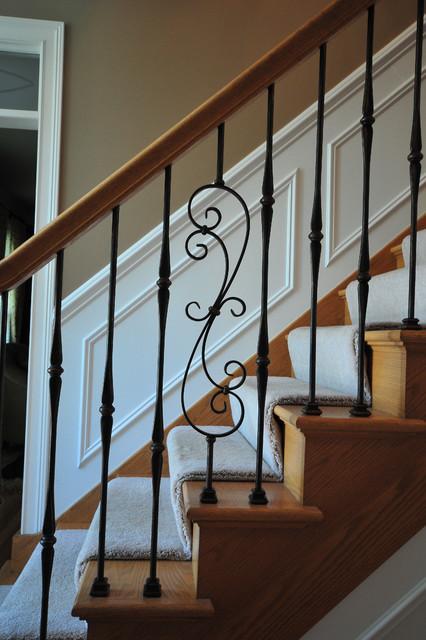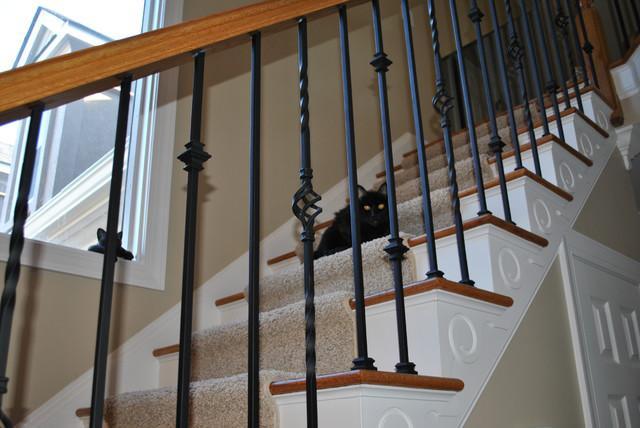The first image is the image on the left, the second image is the image on the right. Assess this claim about the two images: "Each image features a staircase that ascends diagonally from the lower left and has wrought iron bars with some type of decorative embellishment.". Correct or not? Answer yes or no. Yes. The first image is the image on the left, the second image is the image on the right. Evaluate the accuracy of this statement regarding the images: "Exactly one stairway changes directions.". Is it true? Answer yes or no. No. 